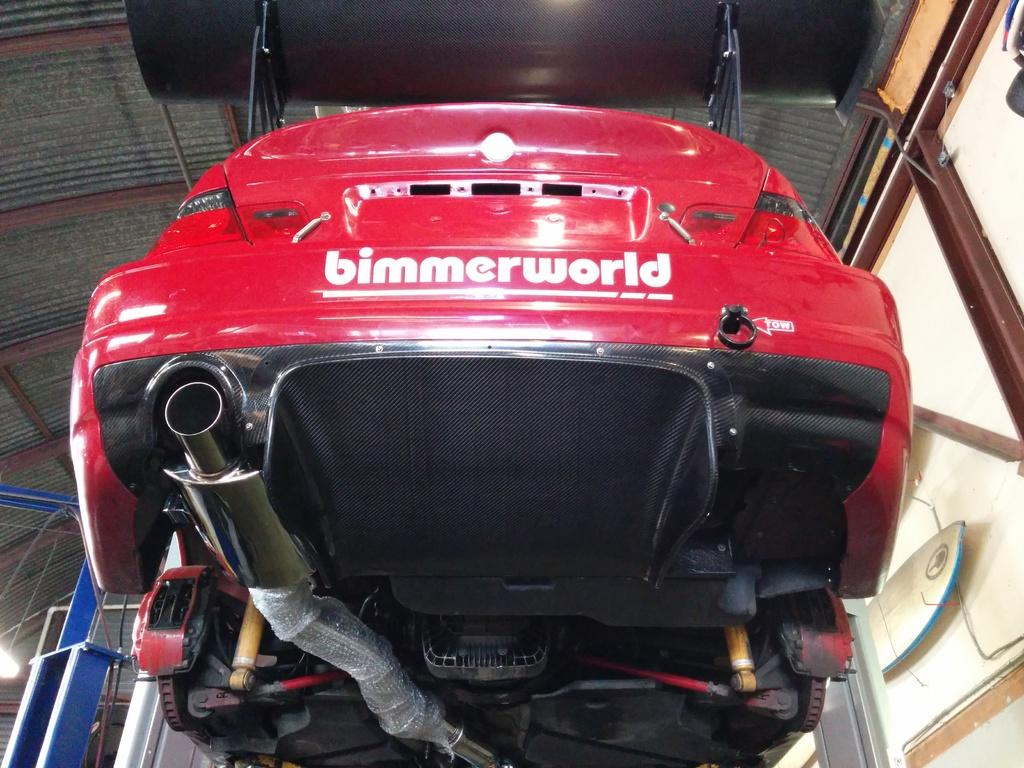What is the main subject of the image? There is a vehicle in the image. What feature does the vehicle have? The vehicle has a silencer. What other parts of the vehicle can be seen in the image? There are other parts of the vehicle visible. What can be seen in the background of the image? There is a roof and poles in the background of the image. How many oranges are on the vehicle in the image? There are no oranges present in the image. Can you see a rat hiding under the vehicle in the image? There is no rat visible in the image. 